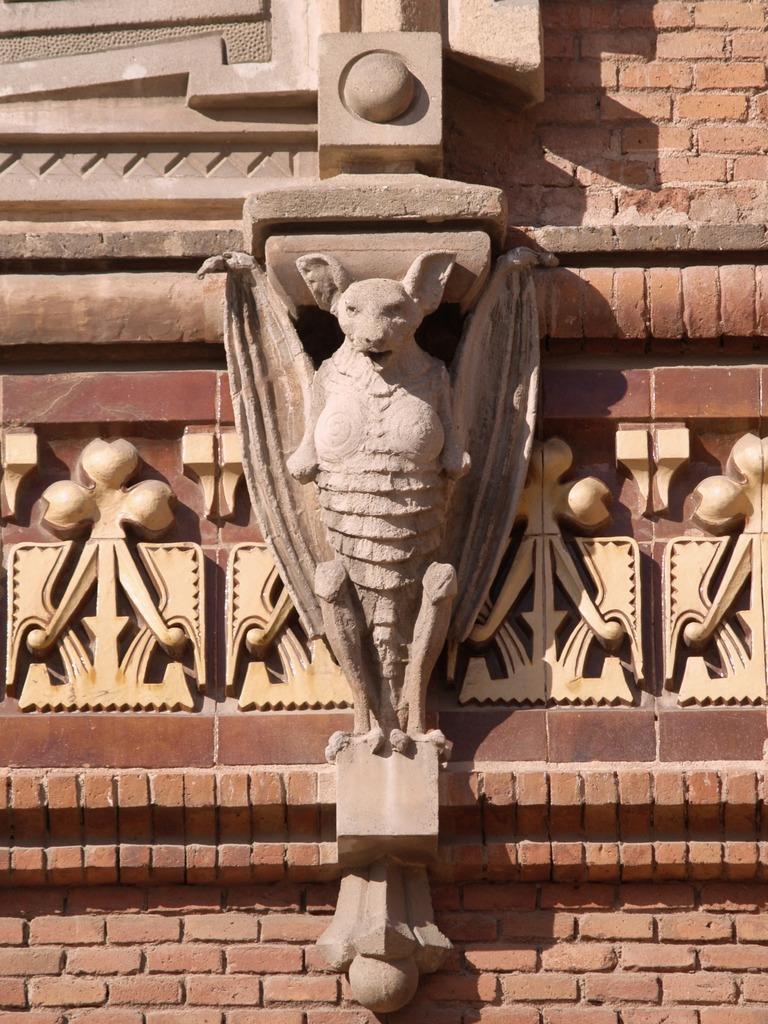In one or two sentences, can you explain what this image depicts? In this image there is a structure of an animal carved on the wall. 